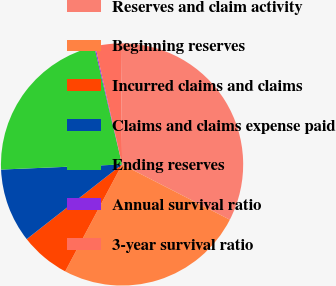<chart> <loc_0><loc_0><loc_500><loc_500><pie_chart><fcel>Reserves and claim activity<fcel>Beginning reserves<fcel>Incurred claims and claims<fcel>Claims and claims expense paid<fcel>Ending reserves<fcel>Annual survival ratio<fcel>3-year survival ratio<nl><fcel>32.69%<fcel>25.24%<fcel>6.65%<fcel>9.9%<fcel>21.99%<fcel>0.14%<fcel>3.39%<nl></chart> 